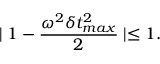Convert formula to latex. <formula><loc_0><loc_0><loc_500><loc_500>| 1 - \frac { \omega ^ { 2 } \delta t _ { \max } ^ { 2 } } { 2 } | \leq 1 .</formula> 